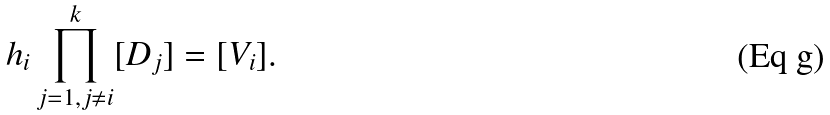<formula> <loc_0><loc_0><loc_500><loc_500>h _ { i } \prod _ { j = 1 , j \not = i } ^ { k } [ D _ { j } ] = [ V _ { i } ] .</formula> 